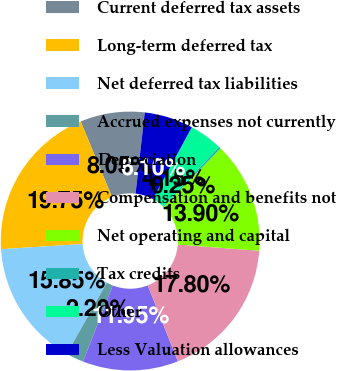Convert chart to OTSL. <chart><loc_0><loc_0><loc_500><loc_500><pie_chart><fcel>Current deferred tax assets<fcel>Long-term deferred tax<fcel>Net deferred tax liabilities<fcel>Accrued expenses not currently<fcel>Depreciation<fcel>Compensation and benefits not<fcel>Net operating and capital<fcel>Tax credits<fcel>Other<fcel>Less Valuation allowances<nl><fcel>8.05%<fcel>19.75%<fcel>15.85%<fcel>2.2%<fcel>11.95%<fcel>17.8%<fcel>13.9%<fcel>0.25%<fcel>4.15%<fcel>6.1%<nl></chart> 